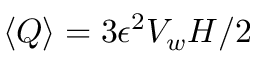<formula> <loc_0><loc_0><loc_500><loc_500>\left < Q \right > = 3 \epsilon ^ { 2 } V _ { w } H / 2</formula> 